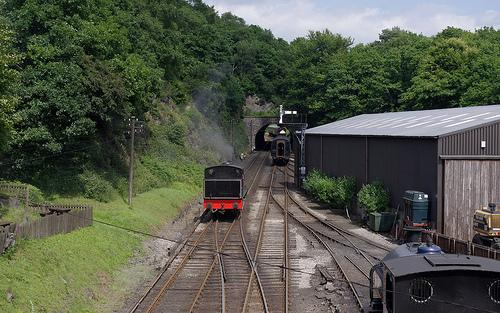Mention one object and its color that is placed near the building in the image. A blue garbage can is on the side of a building. What is the main mode of transportation depicted in the image? Train Is there any mention of smoke in the image description? If yes, where is it coming from? Yes, smoke is coming from the top of the train. What is unique about the landscape around the train tracks? The train tracks lead under a tunnel. Count the number of green bushes mentioned in the description. 4 green bushes What color is the train in the image? The train is black and red. How many train cars are described in the image? 5 train cars Could you tell me if there's any mention of sky in the image description? If yes, what is the sky like? Yes, the sky is cloudy with some blue. Please describe the location of the telephone pole in relation to the train. The telephone pole is to the left of the train. What is the color of the roof of the building mentioned in the description? The roof is gray. What is the relationship between the green bushes and the building? Green bushes are near the building. There's a dog playing on the grass on the hill, isn't there? No, it's not mentioned in the image. Identify the two distinct colors that make up the train's appearance. Black and red What event can be inferred in the image involving the train? The train is heading towards a tunnel. Identify the text in the image involving the color of the roof. The roof is gray Which object in the image has an attribute of being tall? Tall green trees in the background What is the object located left of the train along the ground? A telephone pole While maintaining accuracy, provide an imaginative description of the image. A majestic red and black steam engine chugs along the tracks, venturing towards a mysterious tunnel, with verdant foliage and an intriguing grey building guarding the path. What is the object found on the side of a building in the image? A blue garbage can Is there a fence near the tracks in the image? If so, what color is it? Yes, there is a brown fence near the tracks. Describe the image in a way that emphasizes the setting and surroundings. Surrounded by lush greenery and a majestic cloudy sky, a train makes its way along the tracks, preparing to enter a captivating tunnel, as a grey building stands sentinel nearby. State the main activity taking place in the image. The train is moving along the tracks towards a tunnel. Choose the correct option: What type of fence is on the hill? A. Brown wooden fence B. Metal wire fence C. Concrete fence A. Brown wooden fence Imagine you are standing on the hill, narrate your view of the scene in front of you. Green grass covers the hill, while brown fences march alongside a train on brown tracks, heading for a tunnel with green foliage and an impressive grey building nearby. Why might someone say the train has a split personality? The bottom section of the train is red and the top section is black. What is the large structure closely located near the train tracks? A grey building Imagine that you are looking at the clouds in the sky. How would you describe them? Cloudy sky with some blue patches. What is one of the prominent colors seen on the train? Red and black Describe the scene captured in the image. A red and black train on brown tracks heading towards a tunnel, with green bushes near a large grey building, brown fences on a hill, and a cloudy sky in the background.  